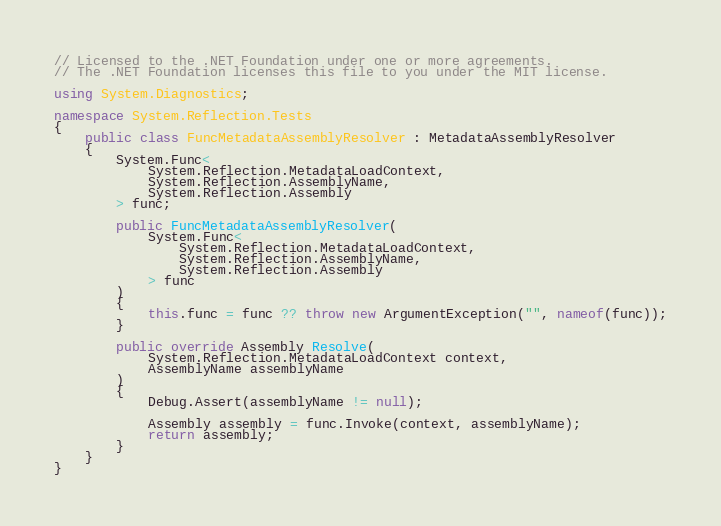Convert code to text. <code><loc_0><loc_0><loc_500><loc_500><_C#_>// Licensed to the .NET Foundation under one or more agreements.
// The .NET Foundation licenses this file to you under the MIT license.

using System.Diagnostics;

namespace System.Reflection.Tests
{
    public class FuncMetadataAssemblyResolver : MetadataAssemblyResolver
    {
        System.Func<
            System.Reflection.MetadataLoadContext,
            System.Reflection.AssemblyName,
            System.Reflection.Assembly
        > func;

        public FuncMetadataAssemblyResolver(
            System.Func<
                System.Reflection.MetadataLoadContext,
                System.Reflection.AssemblyName,
                System.Reflection.Assembly
            > func
        )
        {
            this.func = func ?? throw new ArgumentException("", nameof(func));
        }

        public override Assembly Resolve(
            System.Reflection.MetadataLoadContext context,
            AssemblyName assemblyName
        )
        {
            Debug.Assert(assemblyName != null);

            Assembly assembly = func.Invoke(context, assemblyName);
            return assembly;
        }
    }
}
</code> 